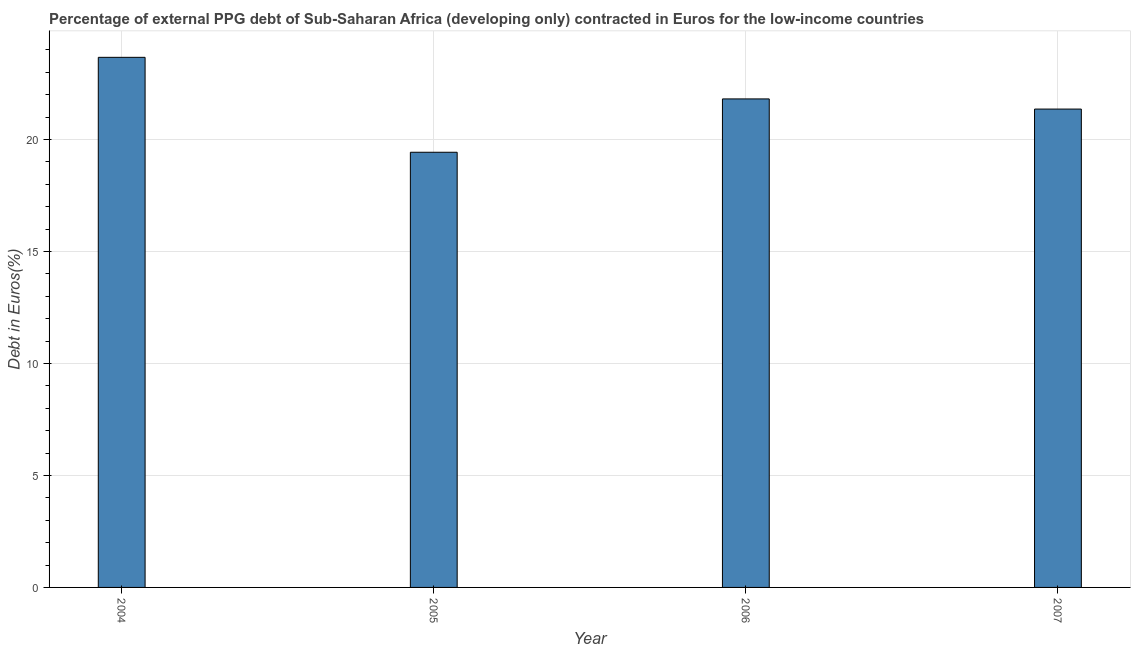What is the title of the graph?
Provide a short and direct response. Percentage of external PPG debt of Sub-Saharan Africa (developing only) contracted in Euros for the low-income countries. What is the label or title of the Y-axis?
Keep it short and to the point. Debt in Euros(%). What is the currency composition of ppg debt in 2006?
Your answer should be compact. 21.81. Across all years, what is the maximum currency composition of ppg debt?
Offer a very short reply. 23.66. Across all years, what is the minimum currency composition of ppg debt?
Offer a terse response. 19.43. In which year was the currency composition of ppg debt minimum?
Give a very brief answer. 2005. What is the sum of the currency composition of ppg debt?
Keep it short and to the point. 86.25. What is the difference between the currency composition of ppg debt in 2006 and 2007?
Give a very brief answer. 0.45. What is the average currency composition of ppg debt per year?
Provide a short and direct response. 21.56. What is the median currency composition of ppg debt?
Your answer should be compact. 21.58. What is the ratio of the currency composition of ppg debt in 2004 to that in 2007?
Give a very brief answer. 1.11. Is the difference between the currency composition of ppg debt in 2004 and 2005 greater than the difference between any two years?
Provide a succinct answer. Yes. What is the difference between the highest and the second highest currency composition of ppg debt?
Keep it short and to the point. 1.86. What is the difference between the highest and the lowest currency composition of ppg debt?
Offer a terse response. 4.24. Are all the bars in the graph horizontal?
Offer a terse response. No. How many years are there in the graph?
Your response must be concise. 4. Are the values on the major ticks of Y-axis written in scientific E-notation?
Make the answer very short. No. What is the Debt in Euros(%) of 2004?
Provide a short and direct response. 23.66. What is the Debt in Euros(%) in 2005?
Offer a very short reply. 19.43. What is the Debt in Euros(%) in 2006?
Ensure brevity in your answer.  21.81. What is the Debt in Euros(%) in 2007?
Make the answer very short. 21.35. What is the difference between the Debt in Euros(%) in 2004 and 2005?
Your answer should be very brief. 4.24. What is the difference between the Debt in Euros(%) in 2004 and 2006?
Offer a terse response. 1.86. What is the difference between the Debt in Euros(%) in 2004 and 2007?
Keep it short and to the point. 2.31. What is the difference between the Debt in Euros(%) in 2005 and 2006?
Provide a short and direct response. -2.38. What is the difference between the Debt in Euros(%) in 2005 and 2007?
Provide a succinct answer. -1.93. What is the difference between the Debt in Euros(%) in 2006 and 2007?
Your answer should be very brief. 0.45. What is the ratio of the Debt in Euros(%) in 2004 to that in 2005?
Offer a terse response. 1.22. What is the ratio of the Debt in Euros(%) in 2004 to that in 2006?
Keep it short and to the point. 1.08. What is the ratio of the Debt in Euros(%) in 2004 to that in 2007?
Provide a short and direct response. 1.11. What is the ratio of the Debt in Euros(%) in 2005 to that in 2006?
Provide a succinct answer. 0.89. What is the ratio of the Debt in Euros(%) in 2005 to that in 2007?
Provide a short and direct response. 0.91. 